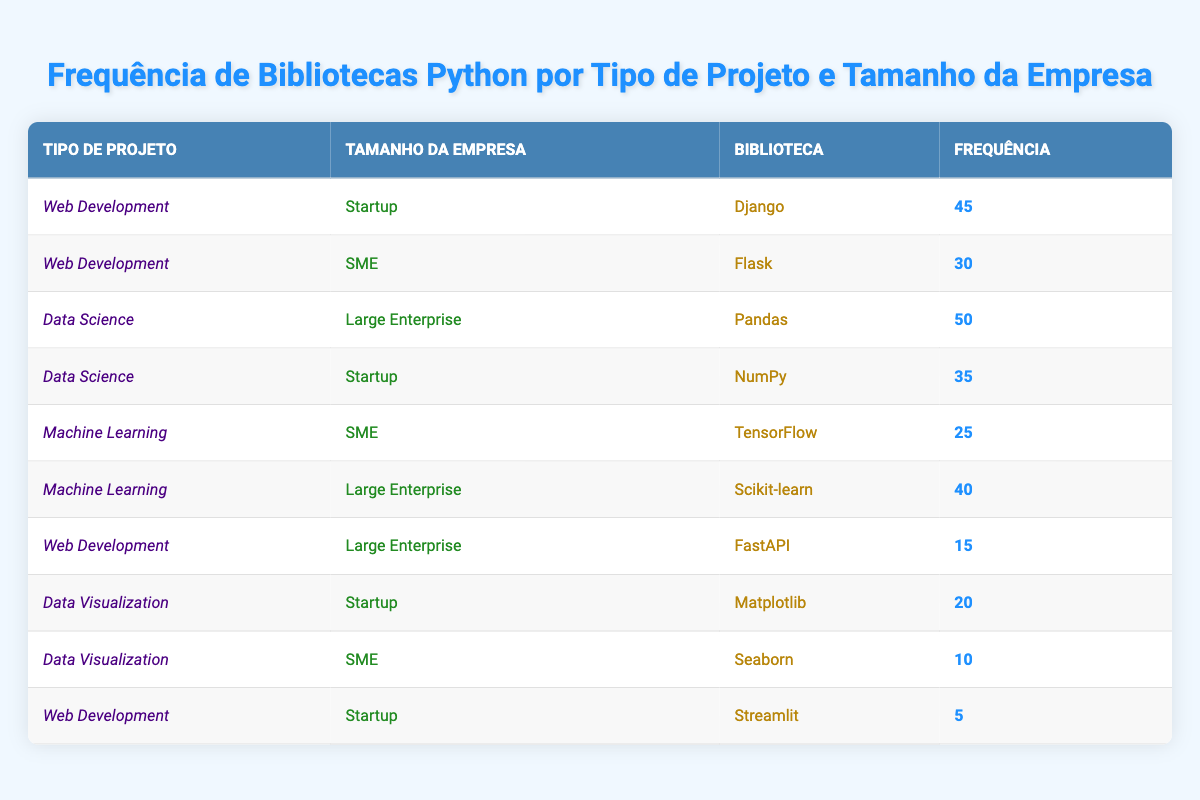What is the most frequently used library in Data Science for Large Enterprises? The table shows that for the "Data Science" project type and "Large Enterprise" company size, the library used is "Pandas" with a frequency of 50. This is the highest frequency in that specific combination.
Answer: Pandas How many libraries are used in Web Development by Startups? Looking at the table, under the "Web Development" project type and "Startup" company size, there are two libraries listed: "Django" and "Streamlit". Therefore, there are 2 libraries used in this category.
Answer: 2 What is the difference in frequency between the highest and lowest used library in the Data Visualization category? In "Data Visualization", the libraries "Matplotlib" (20) and "Seaborn" (10) are listed. The difference in frequency is 20 - 10 = 10.
Answer: 10 Is TensorFlow used more frequently than FastAPI in Machine Learning projects? In the table, "TensorFlow" is used with a frequency of 25 under "Machine Learning" and "SME", while "FastAPI" is used with a frequency of 15 under "Web Development" and "Large Enterprise". Since 25 is greater than 15, TensorFlow is used more frequently than FastAPI.
Answer: Yes What is the total frequency of libraries used in Data Science across all company sizes? Summing the frequencies for the "Data Science" project type yields 50 (Pandas from Large Enterprise) + 35 (NumPy from Startup) = 85. Therefore, the total frequency of libraries used in Data Science is 85.
Answer: 85 Which company size has the highest frequency of library usage in Web Development? Analyzing the "Web Development" project type, the frequencies are 45 for "Django" (Startup), 30 for "Flask" (SME), and 15 for "FastAPI" (Large Enterprise). The highest frequency is 45 for Startups, indicating they have the highest library usage in this category.
Answer: Startup Which library is the least used in the table? By examining the table, "Streamlit" with a frequency of 5 is the least used library. This is lower than all other libraries listed.
Answer: Streamlit How many total libraries are listed for the company size SME? From the table, for the "SME" company size, the libraries used are "Flask" (30 in Web Development) and "Seaborn" (10 in Data Visualization). Therefore, there are 2 libraries listed for SMEs.
Answer: 2 What is the average frequency of libraries used in Machine Learning projects? The libraries listed under "Machine Learning" are "TensorFlow" (25) and "Scikit-learn" (40). Therefore, the average frequency is calculated as (25 + 40) / 2 = 32.5.
Answer: 32.5 